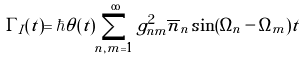Convert formula to latex. <formula><loc_0><loc_0><loc_500><loc_500>\Gamma _ { I } ( t ) = \hbar { \theta } ( t ) \sum ^ { \infty } _ { n , m = 1 } g ^ { 2 } _ { n m } \overline { n } _ { n } \sin ( \Omega _ { n } - \Omega _ { m } ) t</formula> 